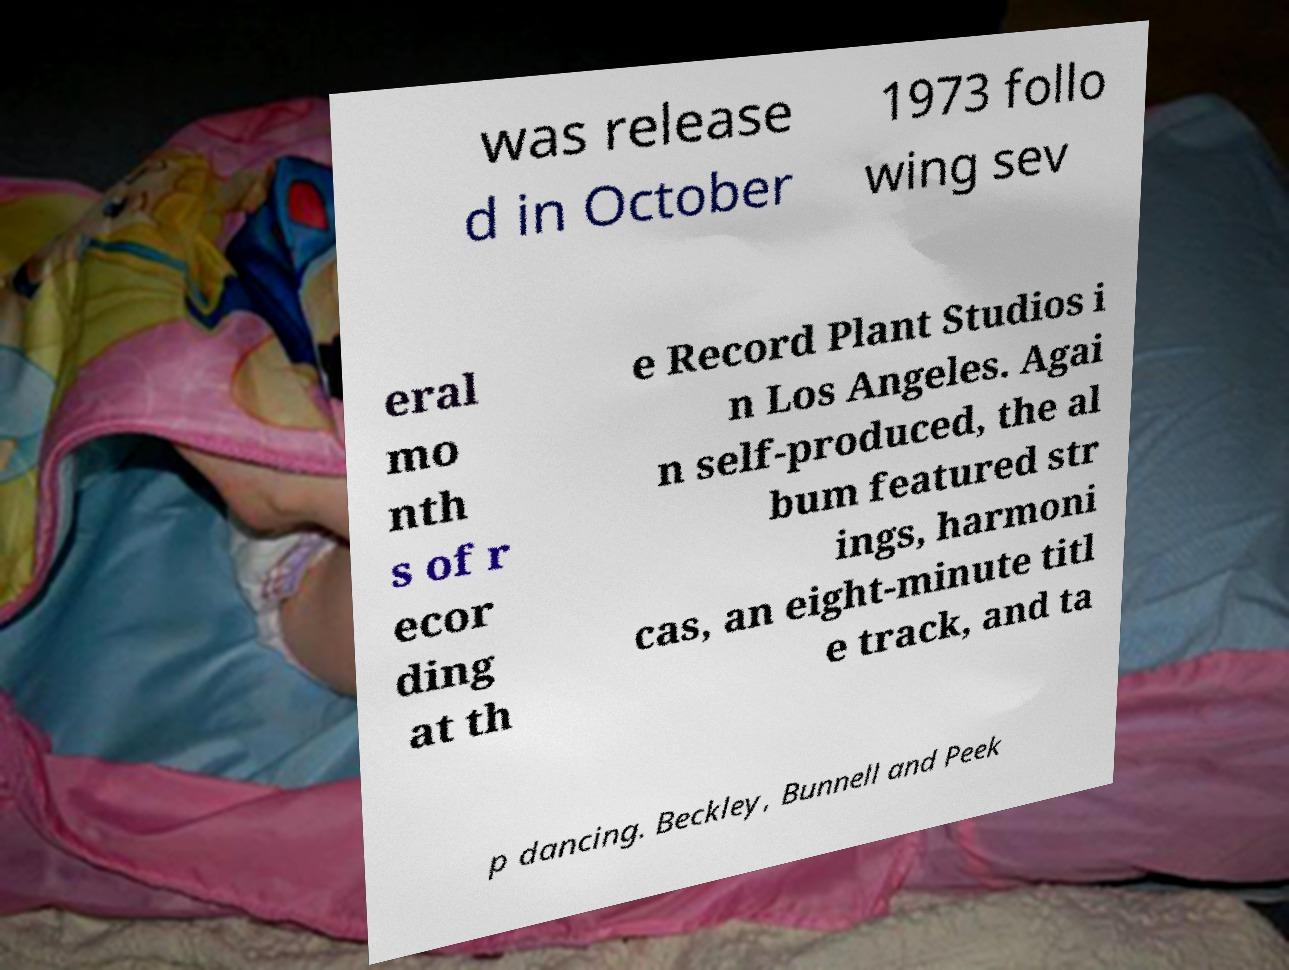Can you read and provide the text displayed in the image?This photo seems to have some interesting text. Can you extract and type it out for me? was release d in October 1973 follo wing sev eral mo nth s of r ecor ding at th e Record Plant Studios i n Los Angeles. Agai n self-produced, the al bum featured str ings, harmoni cas, an eight-minute titl e track, and ta p dancing. Beckley, Bunnell and Peek 